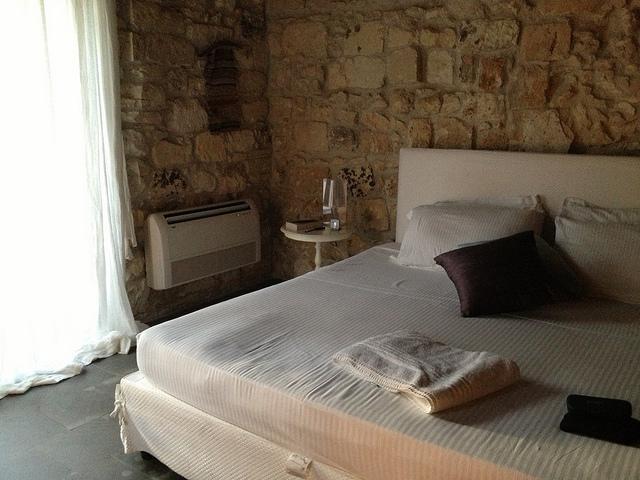How many giraffes are looking away from the camera?
Give a very brief answer. 0. 